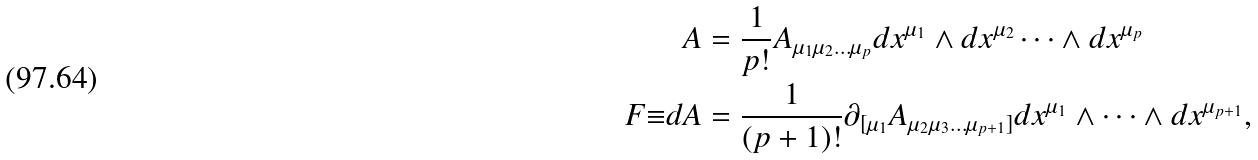<formula> <loc_0><loc_0><loc_500><loc_500>A & = \frac { 1 } { p ! } A _ { \mu _ { 1 } \mu _ { 2 } \dots \mu _ { p } } d x ^ { \mu _ { 1 } } \wedge d x ^ { \mu _ { 2 } } \dots \wedge d x ^ { \mu _ { p } } \\ F { \equiv } d A & = \frac { 1 } { ( p + 1 ) ! } \partial _ { [ \mu _ { 1 } } A _ { \mu _ { 2 } \mu _ { 3 } \dots \mu _ { p + 1 } ] } d x ^ { \mu _ { 1 } } \wedge \dots \wedge d x ^ { \mu _ { p + 1 } } ,</formula> 